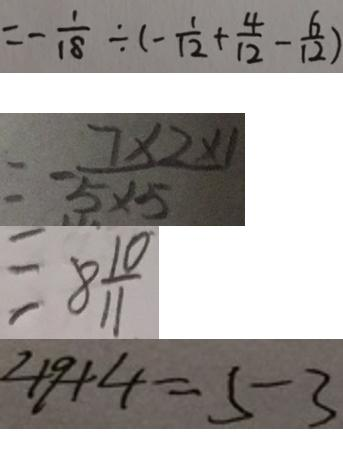Convert formula to latex. <formula><loc_0><loc_0><loc_500><loc_500>= - \frac { 1 } { 1 8 } \div ( - \frac { 1 } { 1 2 } + \frac { 4 } { 1 2 } - \frac { 6 } { 1 2 } ) 
 = - \frac { 7 \times 2 \times 1 } { 5 \times 5 } 
 = 8 \frac { 1 0 } { 1 1 } 
 4 9 + 4 = 5 3</formula> 